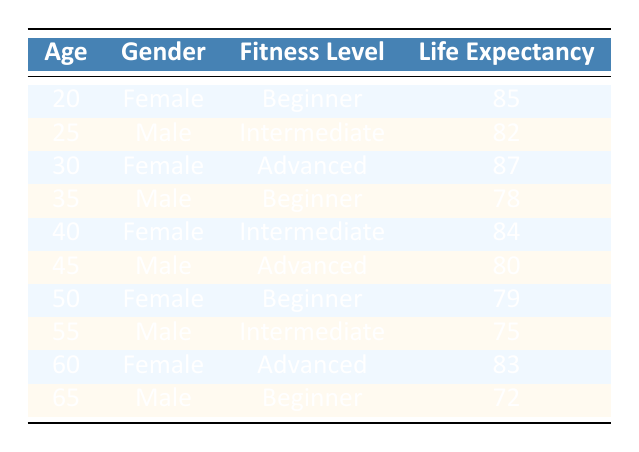What is the life expectancy for a 25-year-old male with an intermediate fitness level? According to the table, a 25-year-old male with an intermediate fitness level has a life expectancy of 82 years.
Answer: 82 What is the life expectancy difference between a 20-year-old female beginner and a 35-year-old male beginner? The life expectancy for a 20-year-old female beginner is 85 years, and for a 35-year-old male beginner, it is 78 years. The difference is 85 - 78 = 7 years.
Answer: 7 Is the life expectancy of a 50-year-old female beginner greater than that of a 60-year-old female advanced? The life expectancy for a 50-year-old female beginner is 79 years, while for a 60-year-old female advanced, it is 83 years. Since 79 is less than 83, the statement is false.
Answer: No What is the average life expectancy of males in the fitness community? The life expectancies for males are 82, 78, 80, 75, and 72. Summing them gives 82 + 78 + 80 + 75 + 72 = 387. There are 5 males, so the average is 387 / 5 = 77.4.
Answer: 77.4 Compare the life expectancy of an advanced fitness female at age 30 with that of a beginner male at age 65. The life expectancy for a 30-year-old female advanced is 87 years, while for a 65-year-old male beginner, it is 72 years. The younger female has a greater life expectancy by 87 - 72 = 15 years.
Answer: 15 How many individuals in the table have a life expectancy of 80 years or more? The individuals with a life expectancy of 80 years or more are: 20-year-old female beginner (85), 30-year-old female advanced (87), 40-year-old female intermediate (84), and 45-year-old male advanced (80). This totals to 4 individuals.
Answer: 4 Which age group has the highest life expectancy among females? The highest life expectancy among females is found at the age of 30 with 87 years. This is the maximum when comparing the life expectancies of 20, 40, and 60-year-old females.
Answer: 30 Is it true that older age groups generally have lower life expectancy values than younger groups? Comparing the age groups from 20 to 35 (85 and 78), the trend holds as younger ages tend to have higher life expectancies. The same pattern is observed for 40 versus 55 and 50 versus 65, confirming that older groups have lower averages overall.
Answer: Yes 